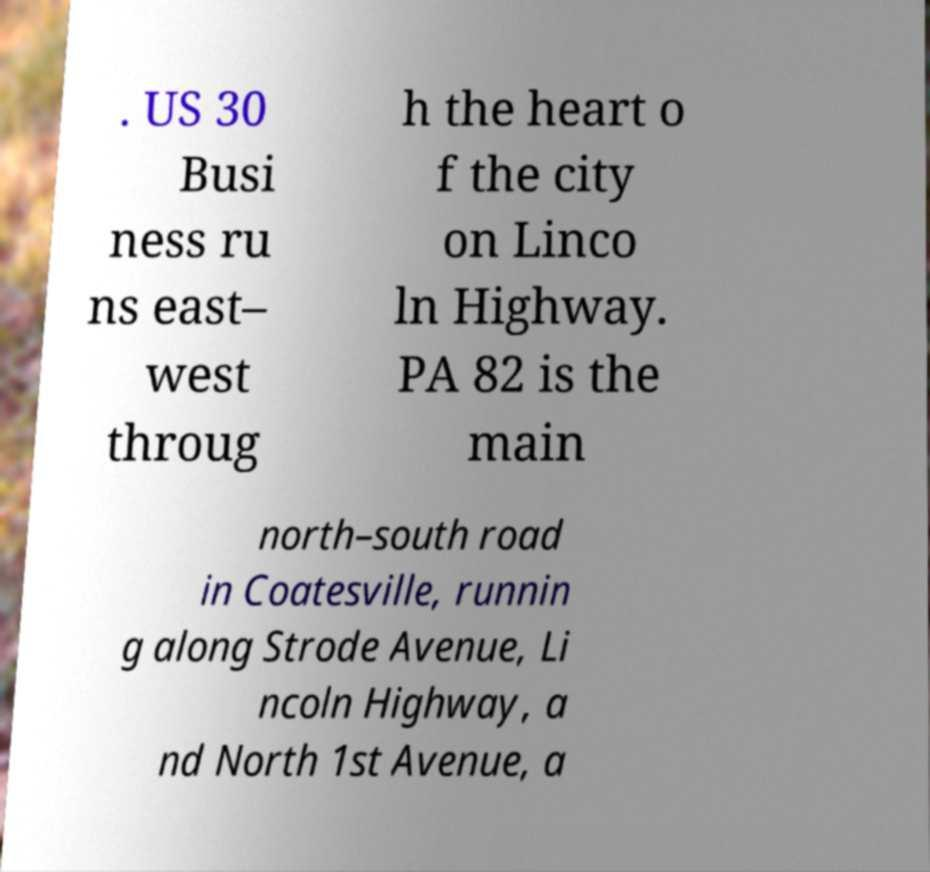Can you accurately transcribe the text from the provided image for me? . US 30 Busi ness ru ns east– west throug h the heart o f the city on Linco ln Highway. PA 82 is the main north–south road in Coatesville, runnin g along Strode Avenue, Li ncoln Highway, a nd North 1st Avenue, a 